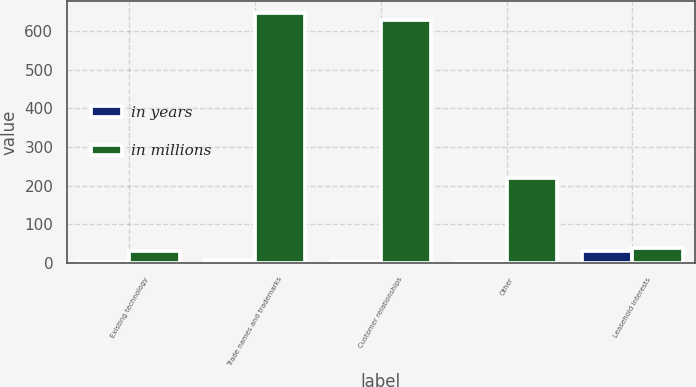Convert chart to OTSL. <chart><loc_0><loc_0><loc_500><loc_500><stacked_bar_chart><ecel><fcel>Existing technology<fcel>Trade names and trademarks<fcel>Customer relationships<fcel>Other<fcel>Leasehold interests<nl><fcel>in years<fcel>3<fcel>7<fcel>6<fcel>2<fcel>31<nl><fcel>in millions<fcel>31<fcel>645<fcel>628<fcel>219<fcel>39<nl></chart> 